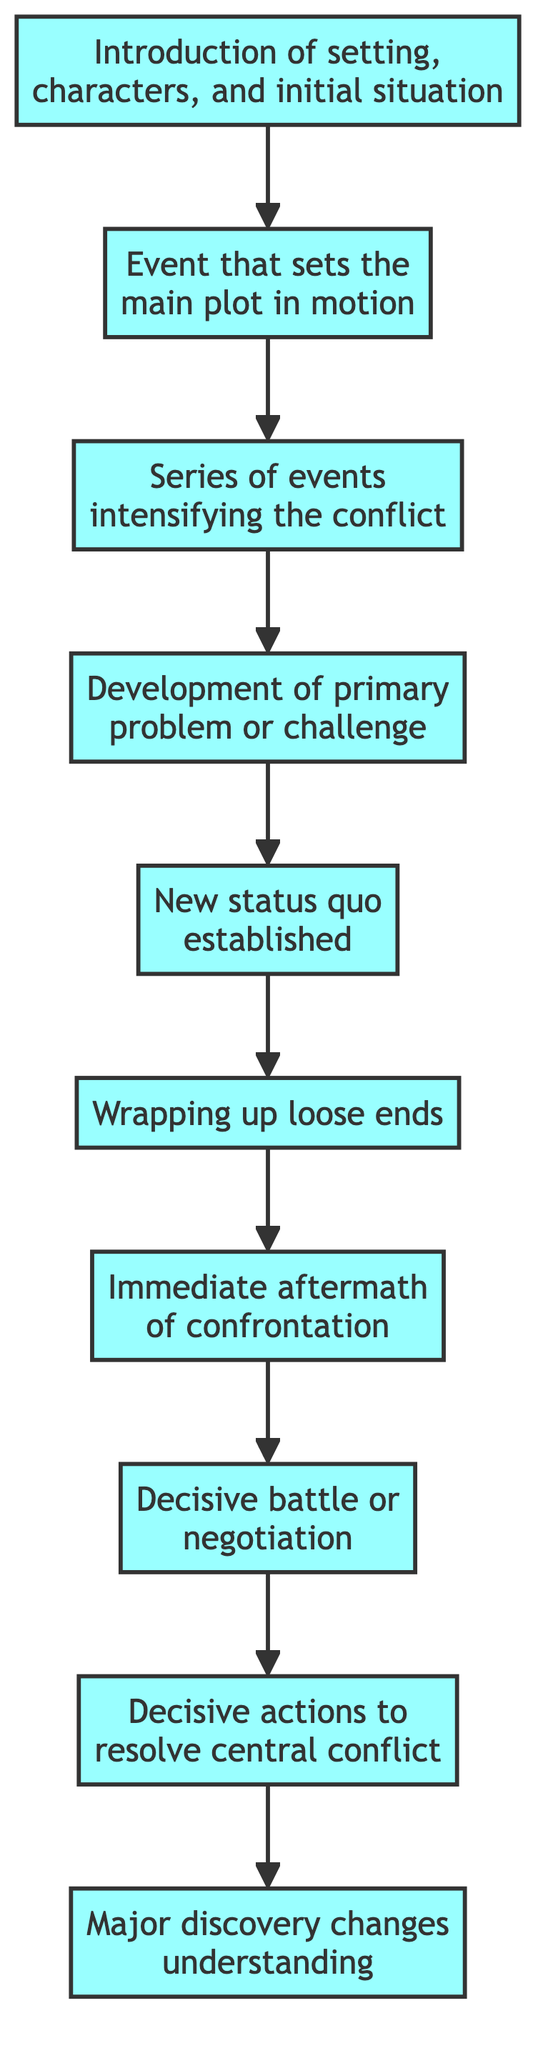What is the first step in the plot progression? The first step is "Establishing Shot," which introduces the setting, characters, and initial situation of the story.
Answer: Establishing Shot What follows after the Inciting Incident? After the "Inciting Incident," the next step in the flow is "Rising Action," indicating a series of events that intensify the conflict.
Answer: Rising Action How many major steps are there in the plot progression? There are a total of ten major steps, starting from "Establishing Shot" to "Climactic Revelation."
Answer: Ten What is the final resolve in the plot progression? The final resolution in the diagram is indicated as "Resolution," marking either a return to normalcy or the establishment of a new status quo.
Answer: Resolution Which step involves a major discovery? The step that involves a major discovery is "Climactic Revelation," where a key event changes the protagonists' understanding of their world.
Answer: Climactic Revelation What is the relationship between Rising Action and Final Confrontation? "Rising Action" leads to the "Main Conflict," which then leads to the "Final Confrontation," showing the escalating intensity of the plot toward the climax.
Answer: Leads to What is the outcome of the Falling Action? The outcome of the "Falling Action" is the "Denouement," where loose ends are wrapped up and the characters begin to deal with the aftermath of the confrontation.
Answer: Denouement What directly precedes the "Climactic Revelation"? The step that directly precedes "Climactic Revelation" is "Resolution Steps," where characters take actions to address the conflict influenced by the revelation.
Answer: Resolution Steps How does the plot start in this flow? The plot starts with the "Establishing Shot," setting the stage for the story by presenting the initial situation and characters involved.
Answer: Establishing Shot 